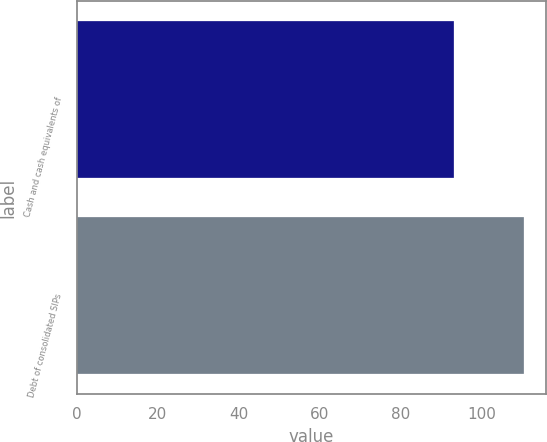<chart> <loc_0><loc_0><loc_500><loc_500><bar_chart><fcel>Cash and cash equivalents of<fcel>Debt of consolidated SIPs<nl><fcel>93.1<fcel>110.4<nl></chart> 